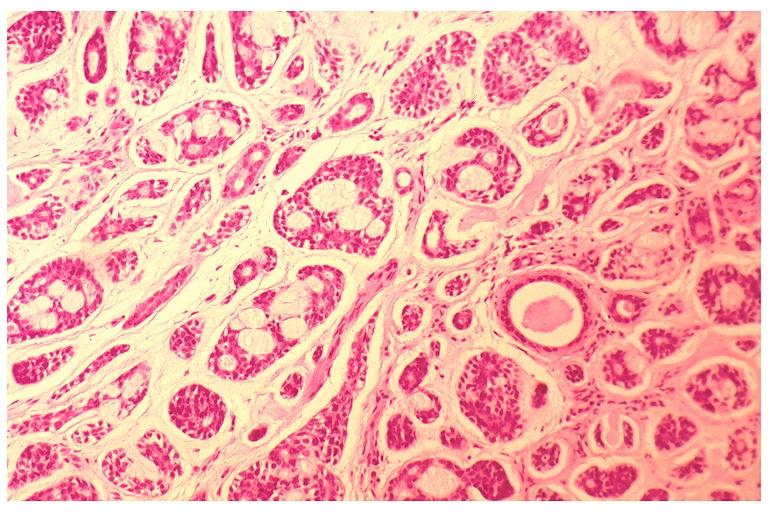s oral present?
Answer the question using a single word or phrase. Yes 